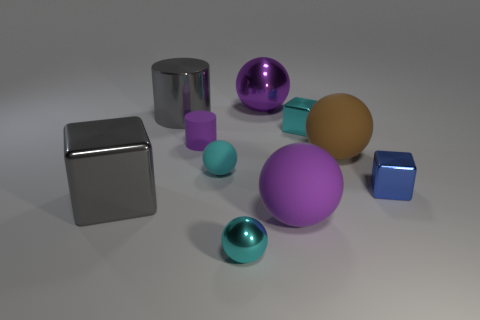Subtract all brown spheres. How many spheres are left? 4 Subtract all tiny cyan rubber spheres. How many spheres are left? 4 Subtract all brown balls. Subtract all brown cubes. How many balls are left? 4 Subtract all blocks. How many objects are left? 7 Add 6 cyan matte objects. How many cyan matte objects exist? 7 Subtract 1 gray cubes. How many objects are left? 9 Subtract all blue blocks. Subtract all tiny blocks. How many objects are left? 7 Add 4 gray blocks. How many gray blocks are left? 5 